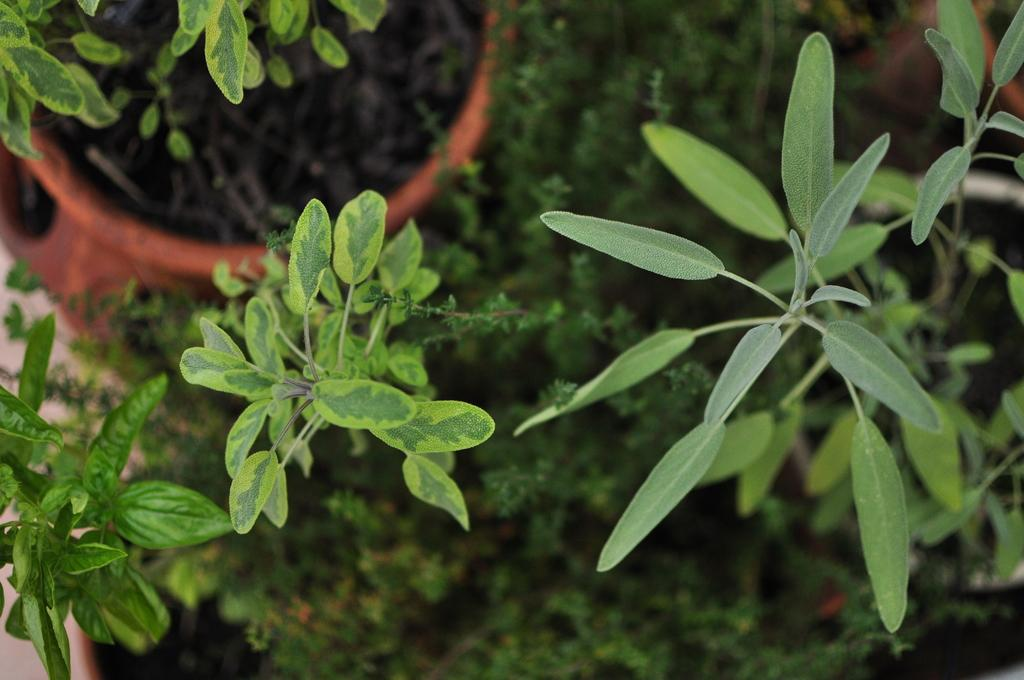What type of living organisms can be seen in the image? Plants can be seen in the image. What is the pot used for in the image? The pot is likely used for containing or growing the plants in the image. How many cows are visible in the image? There are no cows present in the image. What type of rifle is being used to water the plants in the image? There is no rifle present in the image, and plants do not require watering with a rifle. 